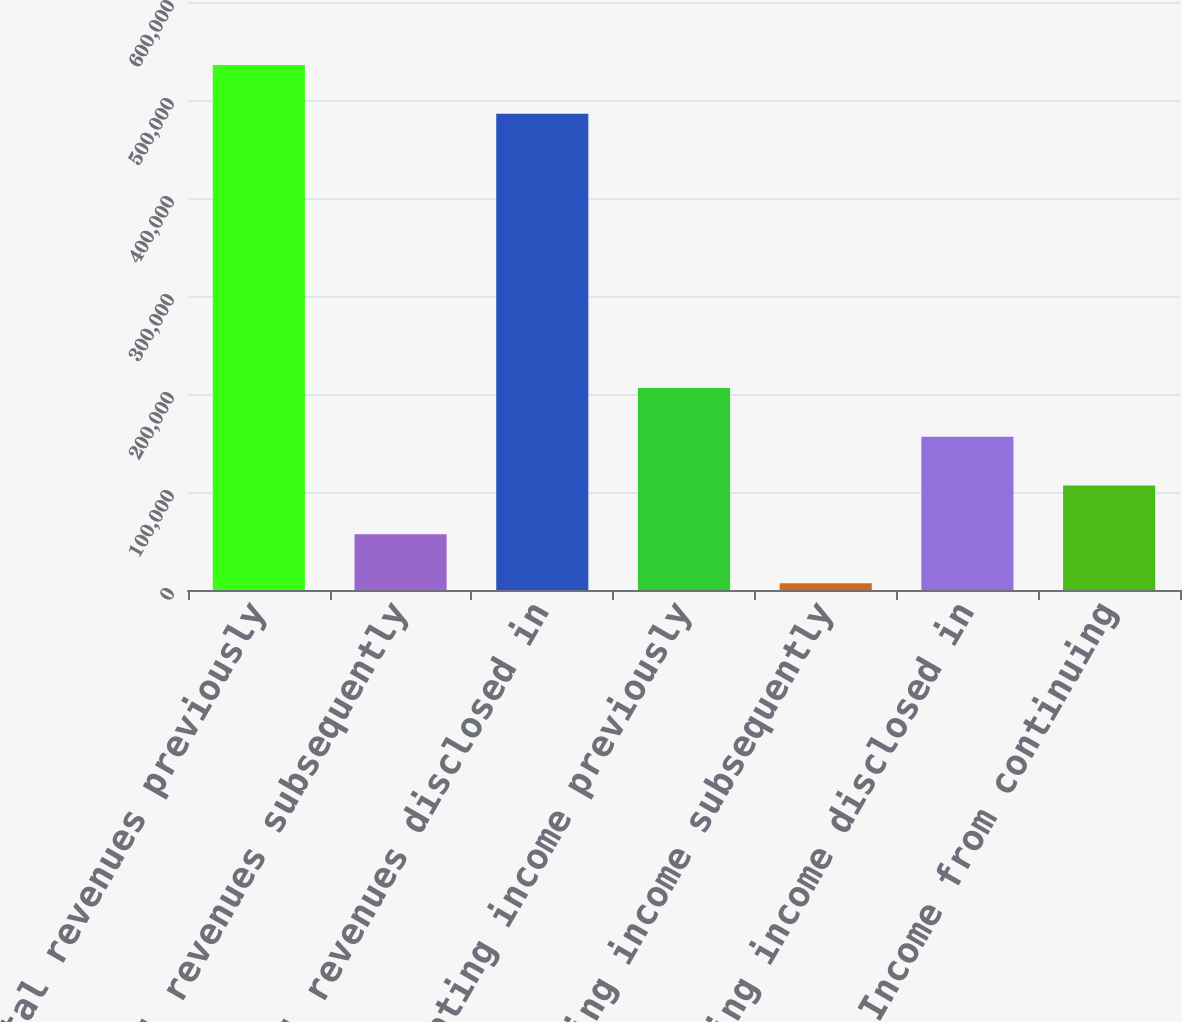Convert chart to OTSL. <chart><loc_0><loc_0><loc_500><loc_500><bar_chart><fcel>Total revenues previously<fcel>Total revenues subsequently<fcel>Total revenues disclosed in<fcel>Operating income previously<fcel>Operating income subsequently<fcel>Operating income disclosed in<fcel>Income from continuing<nl><fcel>535773<fcel>56779<fcel>485954<fcel>206236<fcel>6960<fcel>156417<fcel>106598<nl></chart> 